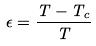<formula> <loc_0><loc_0><loc_500><loc_500>\epsilon = \frac { T - T _ { c } } { T }</formula> 